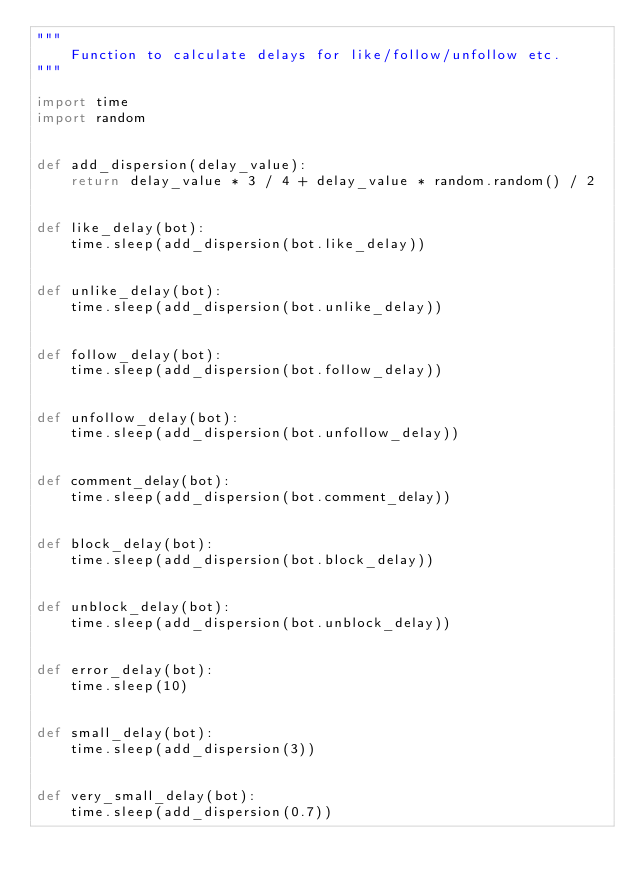<code> <loc_0><loc_0><loc_500><loc_500><_Python_>"""
    Function to calculate delays for like/follow/unfollow etc.
"""

import time
import random


def add_dispersion(delay_value):
    return delay_value * 3 / 4 + delay_value * random.random() / 2


def like_delay(bot):
    time.sleep(add_dispersion(bot.like_delay))


def unlike_delay(bot):
    time.sleep(add_dispersion(bot.unlike_delay))


def follow_delay(bot):
    time.sleep(add_dispersion(bot.follow_delay))


def unfollow_delay(bot):
    time.sleep(add_dispersion(bot.unfollow_delay))


def comment_delay(bot):
    time.sleep(add_dispersion(bot.comment_delay))


def block_delay(bot):
    time.sleep(add_dispersion(bot.block_delay))


def unblock_delay(bot):
    time.sleep(add_dispersion(bot.unblock_delay))


def error_delay(bot):
    time.sleep(10)


def small_delay(bot):
    time.sleep(add_dispersion(3))


def very_small_delay(bot):
    time.sleep(add_dispersion(0.7))
</code> 